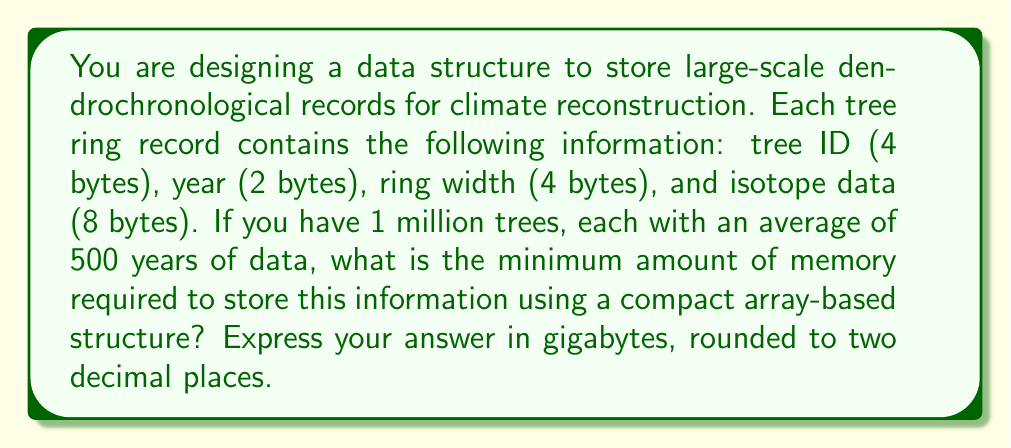What is the answer to this math problem? To solve this problem, we need to follow these steps:

1. Calculate the size of each record:
   - Tree ID: 4 bytes
   - Year: 2 bytes
   - Ring width: 4 bytes
   - Isotope data: 8 bytes
   Total size per record = 4 + 2 + 4 + 8 = 18 bytes

2. Calculate the total number of records:
   Number of trees = 1,000,000
   Average years of data per tree = 500
   Total records = 1,000,000 * 500 = 500,000,000

3. Calculate the total memory required in bytes:
   Total memory = Total records * Size per record
   $$ \text{Total memory} = 500,000,000 * 18 = 9,000,000,000 \text{ bytes} $$

4. Convert bytes to gigabytes:
   $$ \text{Memory in GB} = \frac{9,000,000,000 \text{ bytes}}{1,073,741,824 \text{ bytes/GB}} $$
   $$ = 8.38190317153930664 \text{ GB} $$

5. Round to two decimal places:
   8.38 GB

This calculation assumes a compact array-based structure where the data is stored contiguously without any additional overhead for indexing or metadata. In practice, you might need slightly more memory for efficient data access and management.
Answer: 8.38 GB 